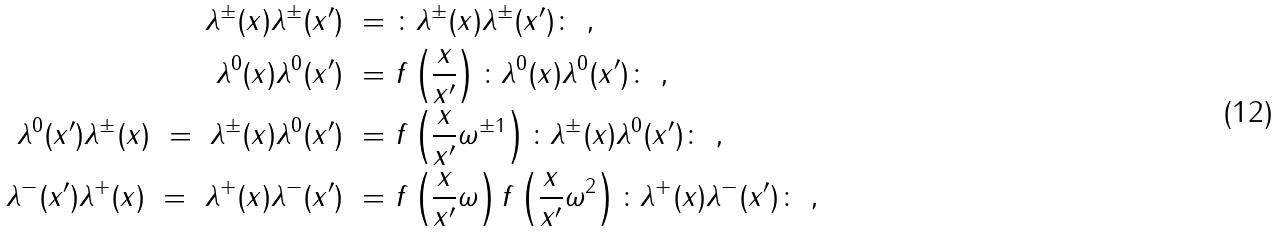<formula> <loc_0><loc_0><loc_500><loc_500>\lambda ^ { \pm } ( x ) \lambda ^ { \pm } ( x ^ { \prime } ) \ = & \ \colon \lambda ^ { \pm } ( x ) \lambda ^ { \pm } ( x ^ { \prime } ) \colon \ , \\ \lambda ^ { 0 } ( x ) \lambda ^ { 0 } ( x ^ { \prime } ) \ = & \ f \left ( \frac { x } { x ^ { \prime } } \right ) \colon \lambda ^ { 0 } ( x ) \lambda ^ { 0 } ( x ^ { \prime } ) \colon \ , \\ \lambda ^ { 0 } ( x ^ { \prime } ) \lambda ^ { \pm } ( x ) \ = \ \lambda ^ { \pm } ( x ) \lambda ^ { 0 } ( x ^ { \prime } ) \ = & \ f \left ( \frac { x } { x ^ { \prime } } \omega ^ { \pm 1 } \right ) \colon \lambda ^ { \pm } ( x ) \lambda ^ { 0 } ( x ^ { \prime } ) \colon \ , \\ \lambda ^ { - } ( x ^ { \prime } ) \lambda ^ { + } ( x ) \ = \ \lambda ^ { + } ( x ) \lambda ^ { - } ( x ^ { \prime } ) \ = & \ f \left ( \frac { x } { x ^ { \prime } } \omega \right ) f \left ( \frac { x } { x ^ { \prime } } \omega ^ { 2 } \right ) \colon \lambda ^ { + } ( x ) \lambda ^ { - } ( x ^ { \prime } ) \colon \ ,</formula> 